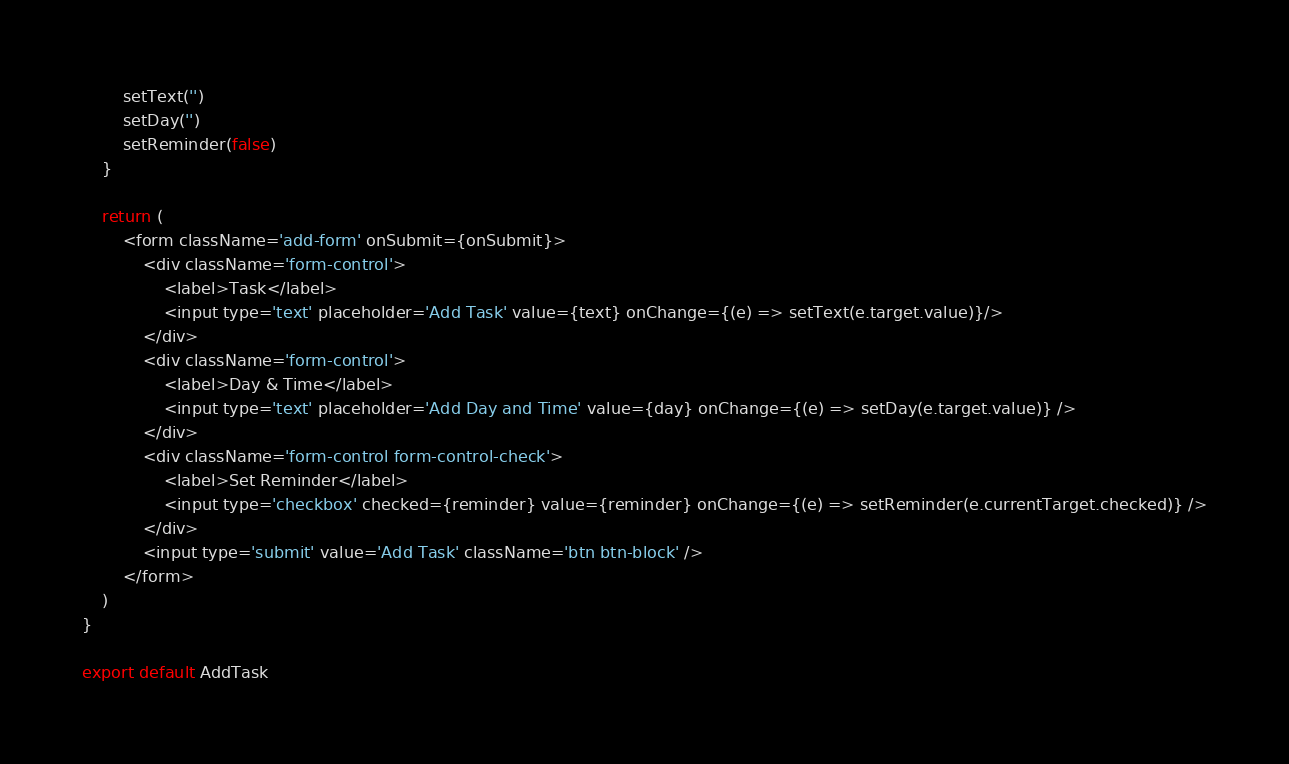<code> <loc_0><loc_0><loc_500><loc_500><_JavaScript_>        setText('')
        setDay('')
        setReminder(false)
    }

    return (
        <form className='add-form' onSubmit={onSubmit}>
            <div className='form-control'>
                <label>Task</label>
                <input type='text' placeholder='Add Task' value={text} onChange={(e) => setText(e.target.value)}/>
            </div>
            <div className='form-control'>
                <label>Day & Time</label>
                <input type='text' placeholder='Add Day and Time' value={day} onChange={(e) => setDay(e.target.value)} />
            </div>
            <div className='form-control form-control-check'>
                <label>Set Reminder</label>
                <input type='checkbox' checked={reminder} value={reminder} onChange={(e) => setReminder(e.currentTarget.checked)} />
            </div>
            <input type='submit' value='Add Task' className='btn btn-block' />
        </form>
    )
}

export default AddTask
</code> 